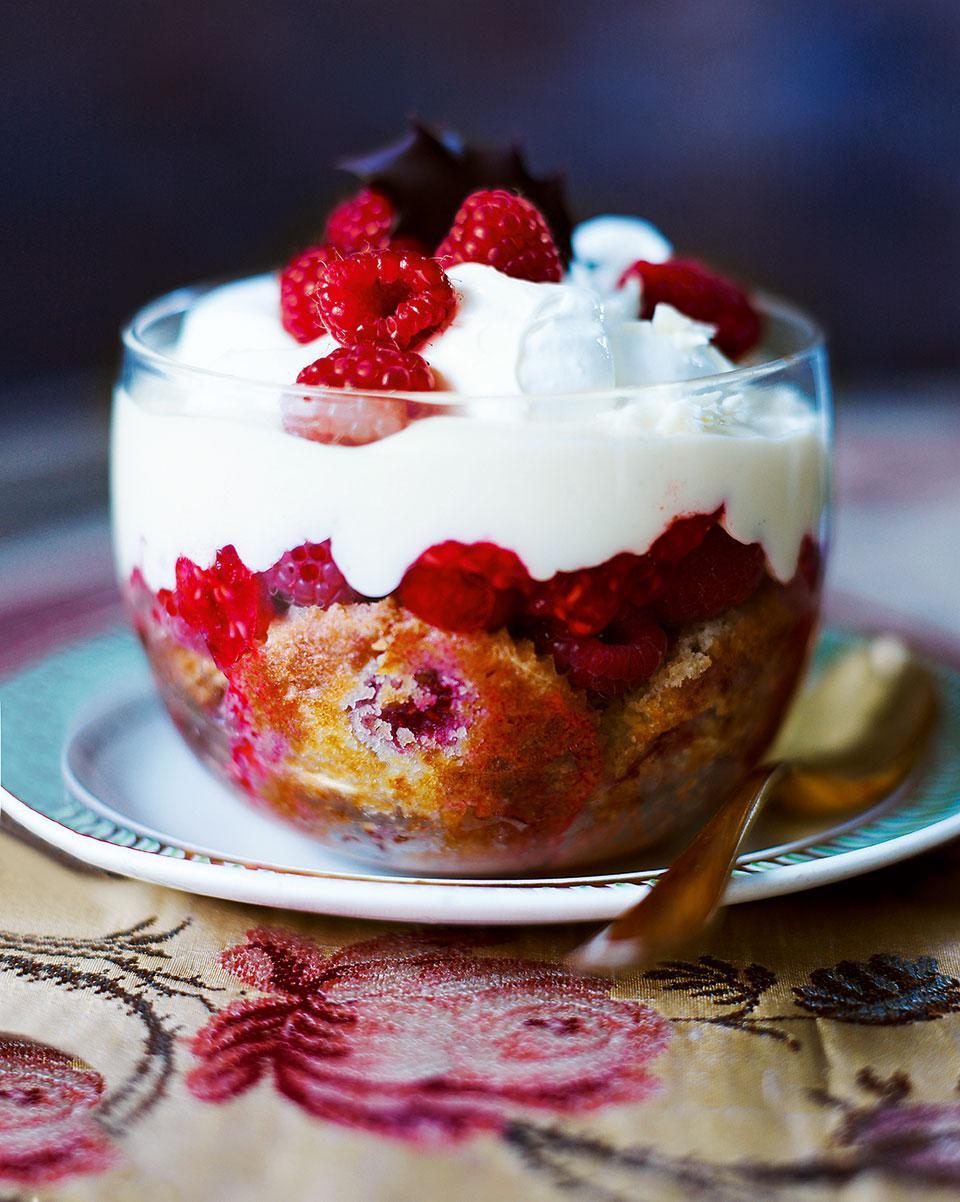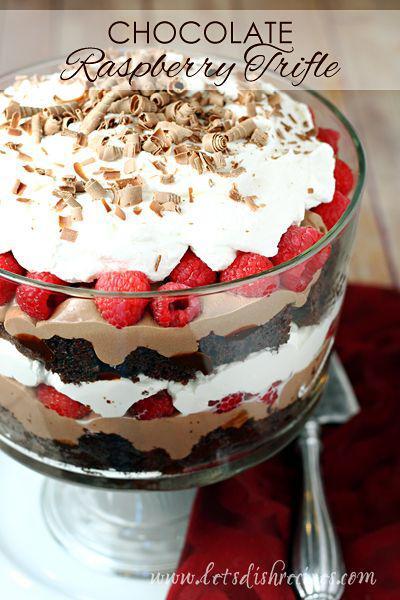The first image is the image on the left, the second image is the image on the right. For the images shown, is this caption "At least one dessert is topped with brown shavings and served in a footed glass." true? Answer yes or no. Yes. 